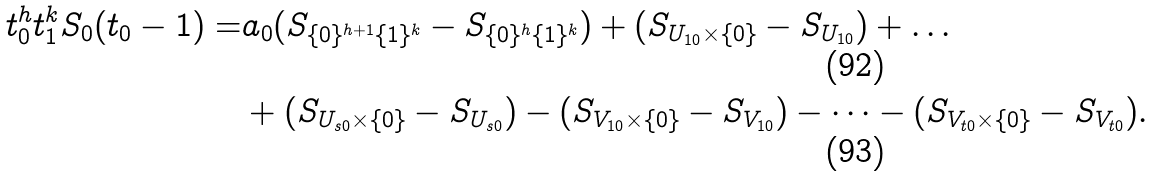Convert formula to latex. <formula><loc_0><loc_0><loc_500><loc_500>t _ { 0 } ^ { h } t _ { 1 } ^ { k } S _ { 0 } ( t _ { 0 } - 1 ) = & a _ { 0 } ( S _ { \{ 0 \} ^ { h + 1 } \{ 1 \} ^ { k } } - S _ { \{ 0 \} ^ { h } \{ 1 \} ^ { k } } ) + ( S _ { U _ { 1 0 } \times \{ 0 \} } - S _ { U _ { 1 0 } } ) + \dots \\ & + ( S _ { U _ { s 0 } \times \{ 0 \} } - S _ { U _ { s 0 } } ) - ( S _ { V _ { 1 0 } \times \{ 0 \} } - S _ { V _ { 1 0 } } ) - \dots - ( S _ { V _ { t 0 } \times \{ 0 \} } - S _ { V _ { t 0 } } ) .</formula> 